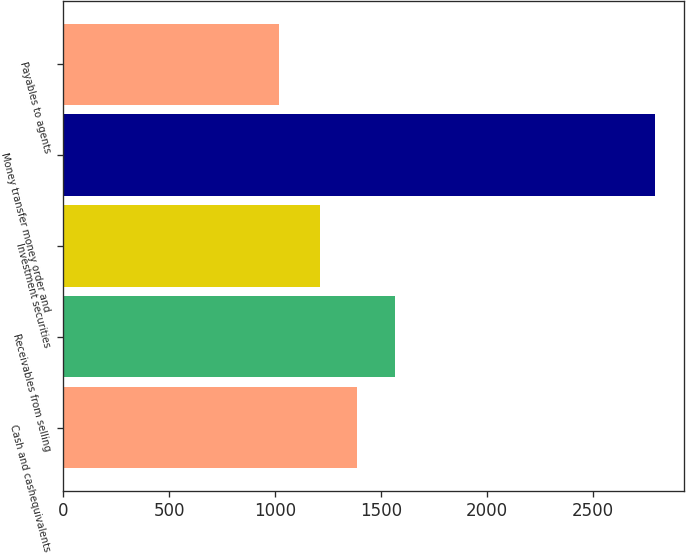Convert chart. <chart><loc_0><loc_0><loc_500><loc_500><bar_chart><fcel>Cash and cashequivalents<fcel>Receivables from selling<fcel>Investment securities<fcel>Money transfer money order and<fcel>Payables to agents<nl><fcel>1387.94<fcel>1565.28<fcel>1210.6<fcel>2793.6<fcel>1020.2<nl></chart> 